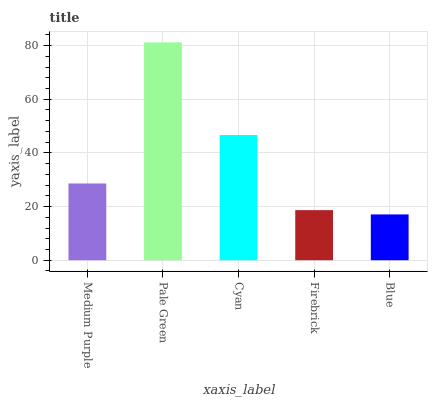Is Blue the minimum?
Answer yes or no. Yes. Is Pale Green the maximum?
Answer yes or no. Yes. Is Cyan the minimum?
Answer yes or no. No. Is Cyan the maximum?
Answer yes or no. No. Is Pale Green greater than Cyan?
Answer yes or no. Yes. Is Cyan less than Pale Green?
Answer yes or no. Yes. Is Cyan greater than Pale Green?
Answer yes or no. No. Is Pale Green less than Cyan?
Answer yes or no. No. Is Medium Purple the high median?
Answer yes or no. Yes. Is Medium Purple the low median?
Answer yes or no. Yes. Is Blue the high median?
Answer yes or no. No. Is Cyan the low median?
Answer yes or no. No. 